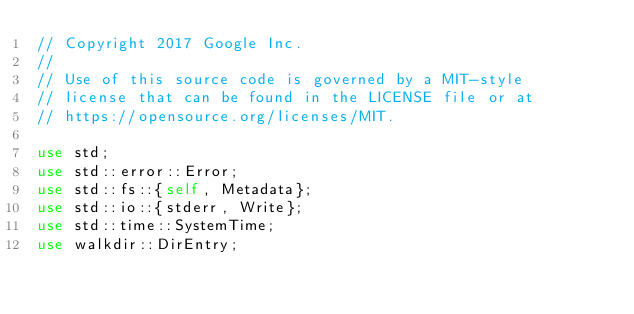Convert code to text. <code><loc_0><loc_0><loc_500><loc_500><_Rust_>// Copyright 2017 Google Inc.
//
// Use of this source code is governed by a MIT-style
// license that can be found in the LICENSE file or at
// https://opensource.org/licenses/MIT.

use std;
use std::error::Error;
use std::fs::{self, Metadata};
use std::io::{stderr, Write};
use std::time::SystemTime;
use walkdir::DirEntry;
</code> 